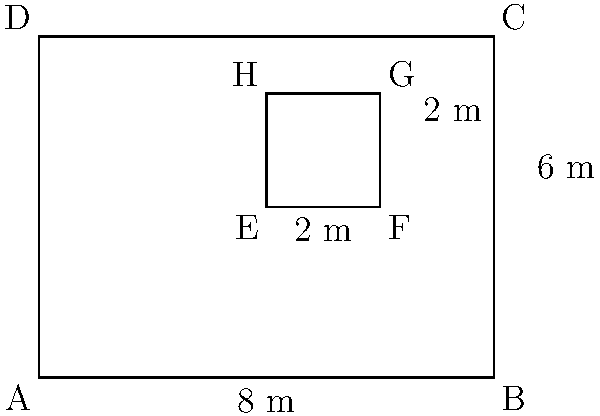As a property owner considering restaurant expansion, you're presented with two potential floor plans. The outer rectangle ABCD represents the current restaurant space, while the inner rectangle EFGH is a proposed kitchen area. If the current restaurant space has dimensions of 8m by 6m, and the proposed kitchen area is 2m by 2m, what percentage of the total restaurant area would the kitchen occupy? Let's approach this step-by-step:

1. Calculate the area of the entire restaurant (ABCD):
   $A_{restaurant} = 8m \times 6m = 48m^2$

2. Calculate the area of the proposed kitchen (EFGH):
   $A_{kitchen} = 2m \times 2m = 4m^2$

3. To find the percentage, we use the formula:
   $Percentage = \frac{A_{kitchen}}{A_{restaurant}} \times 100\%$

4. Substituting the values:
   $Percentage = \frac{4m^2}{48m^2} \times 100\%$

5. Simplify:
   $Percentage = \frac{1}{12} \times 100\% = 8.33\%$

Therefore, the kitchen would occupy approximately 8.33% of the total restaurant area.
Answer: 8.33% 